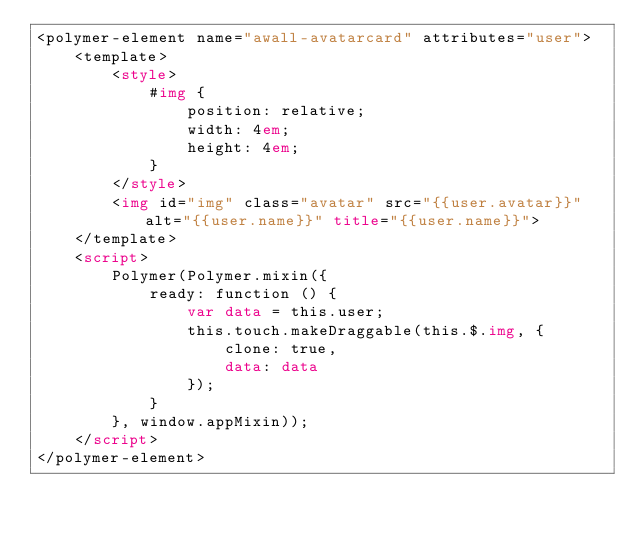Convert code to text. <code><loc_0><loc_0><loc_500><loc_500><_HTML_><polymer-element name="awall-avatarcard" attributes="user">
    <template>
        <style>
            #img {
                position: relative;
                width: 4em;
                height: 4em;
            }
        </style>
        <img id="img" class="avatar" src="{{user.avatar}}" alt="{{user.name}}" title="{{user.name}}">
    </template>
    <script>
        Polymer(Polymer.mixin({
            ready: function () {
                var data = this.user;
                this.touch.makeDraggable(this.$.img, {
                    clone: true,
                    data: data
                });
            }
        }, window.appMixin));
    </script>
</polymer-element></code> 